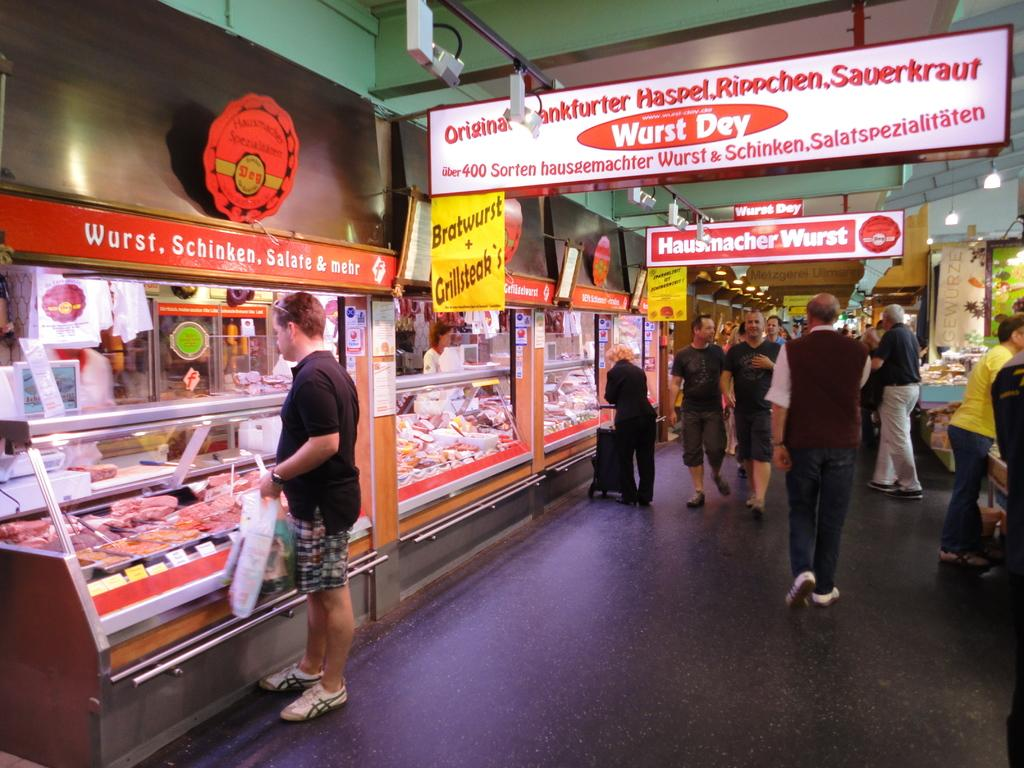<image>
Provide a brief description of the given image. A group of customers stroll passed a Wurst Dey meat shop. 